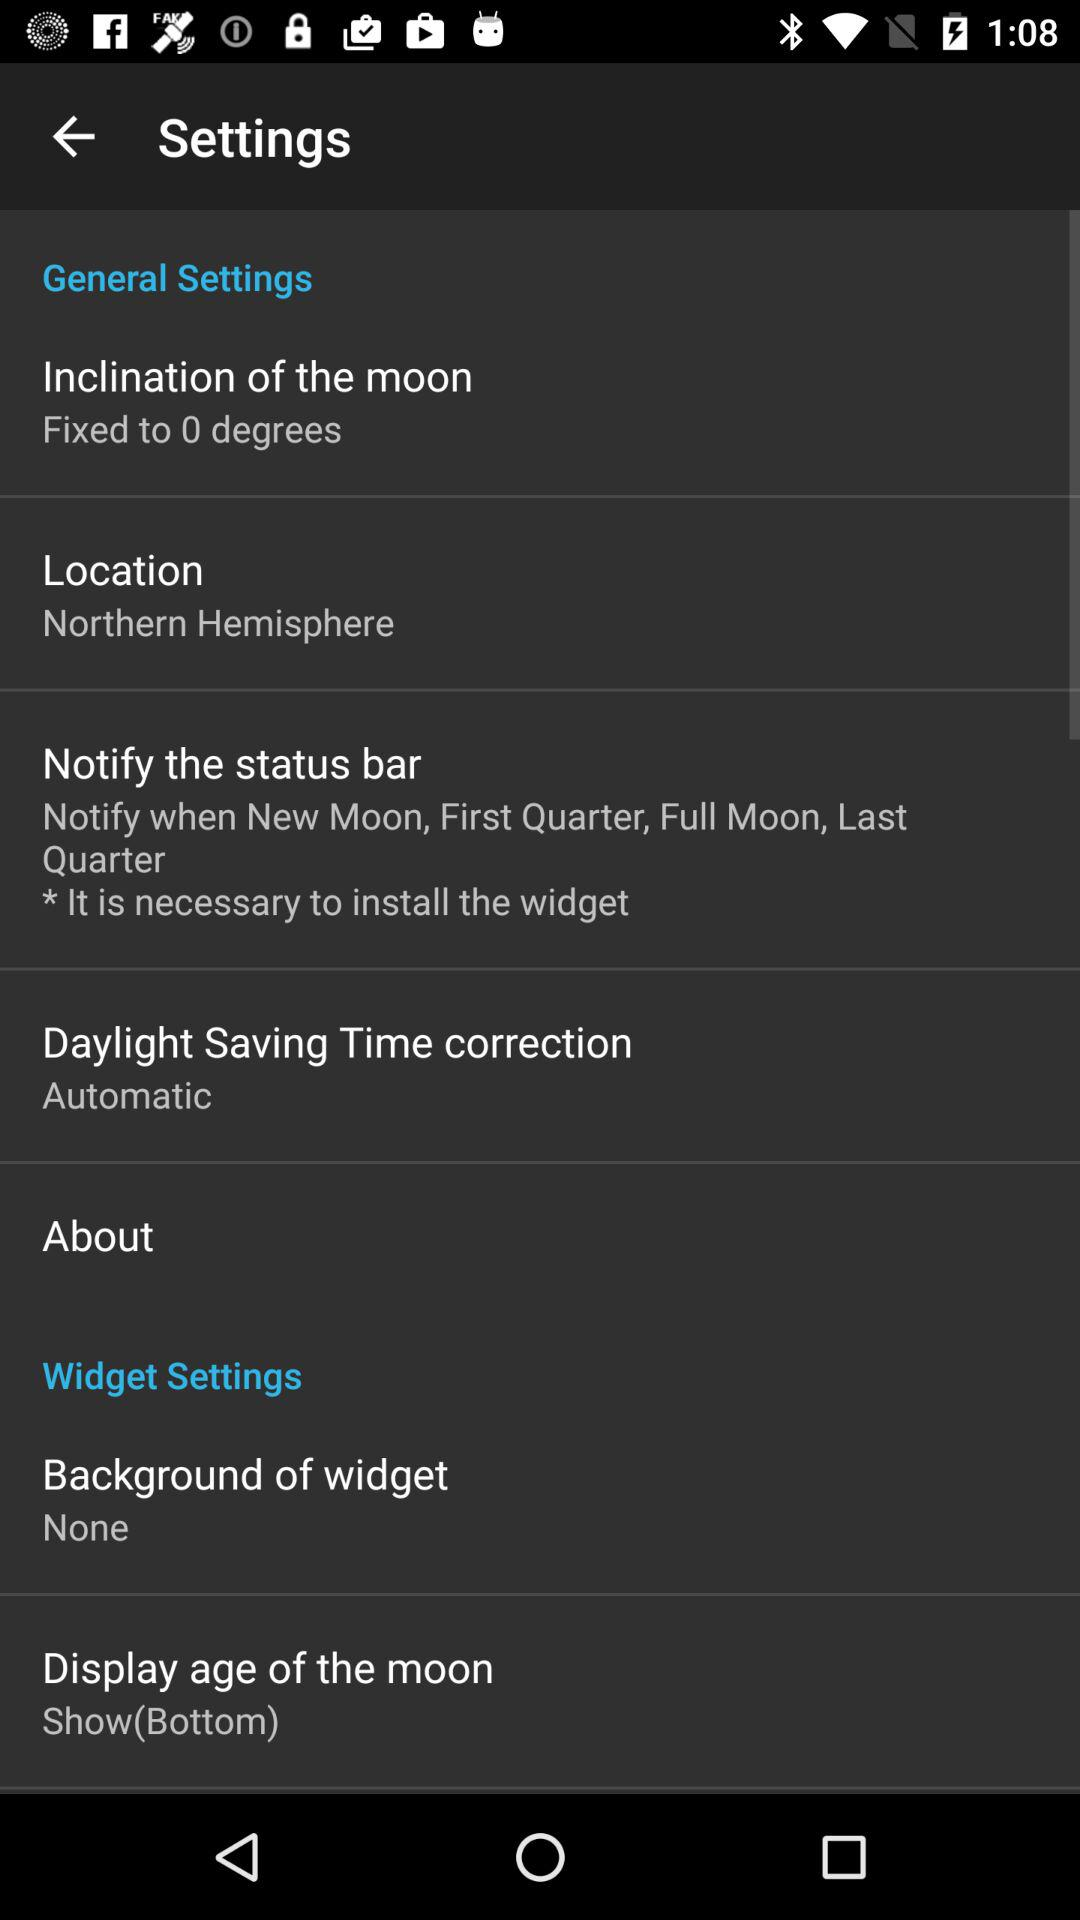What is the setting for the inclination of the moon? The setting for the inclination of the moon is "Fixed to 0 degrees". 